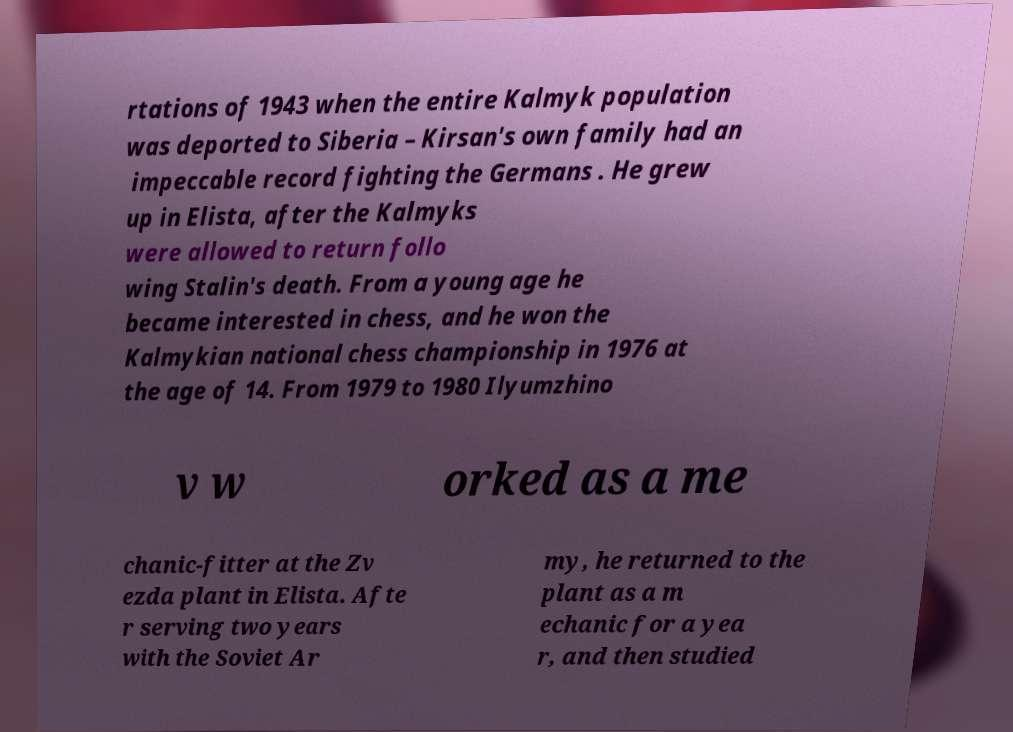Could you assist in decoding the text presented in this image and type it out clearly? rtations of 1943 when the entire Kalmyk population was deported to Siberia – Kirsan's own family had an impeccable record fighting the Germans . He grew up in Elista, after the Kalmyks were allowed to return follo wing Stalin's death. From a young age he became interested in chess, and he won the Kalmykian national chess championship in 1976 at the age of 14. From 1979 to 1980 Ilyumzhino v w orked as a me chanic-fitter at the Zv ezda plant in Elista. Afte r serving two years with the Soviet Ar my, he returned to the plant as a m echanic for a yea r, and then studied 